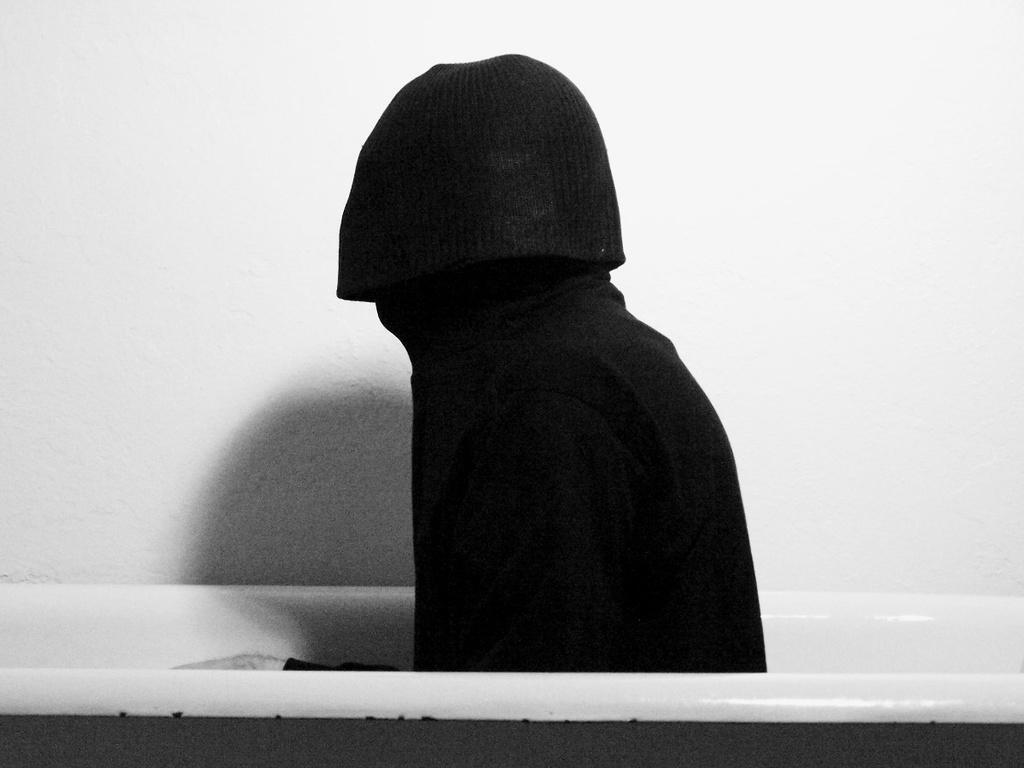Could you give a brief overview of what you see in this image? In this image there is one bathtub and in the tub there's one person, and in the background there is a wall. 